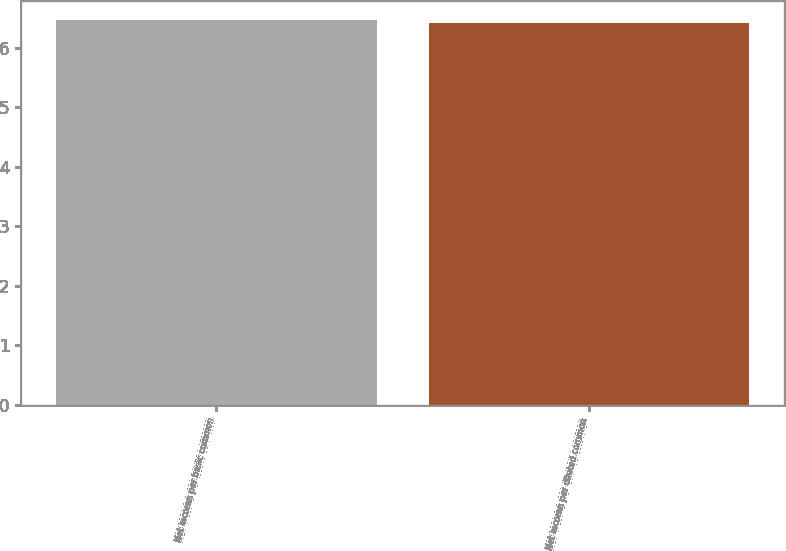Convert chart. <chart><loc_0><loc_0><loc_500><loc_500><bar_chart><fcel>Net income per basic common<fcel>Net income per diluted common<nl><fcel>6.46<fcel>6.41<nl></chart> 